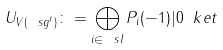<formula> <loc_0><loc_0><loc_500><loc_500>U _ { V ( \ s g ^ { f } ) } \colon = \bigoplus _ { i \in \ s I } P _ { i } ( - 1 ) | 0 \ k e t</formula> 